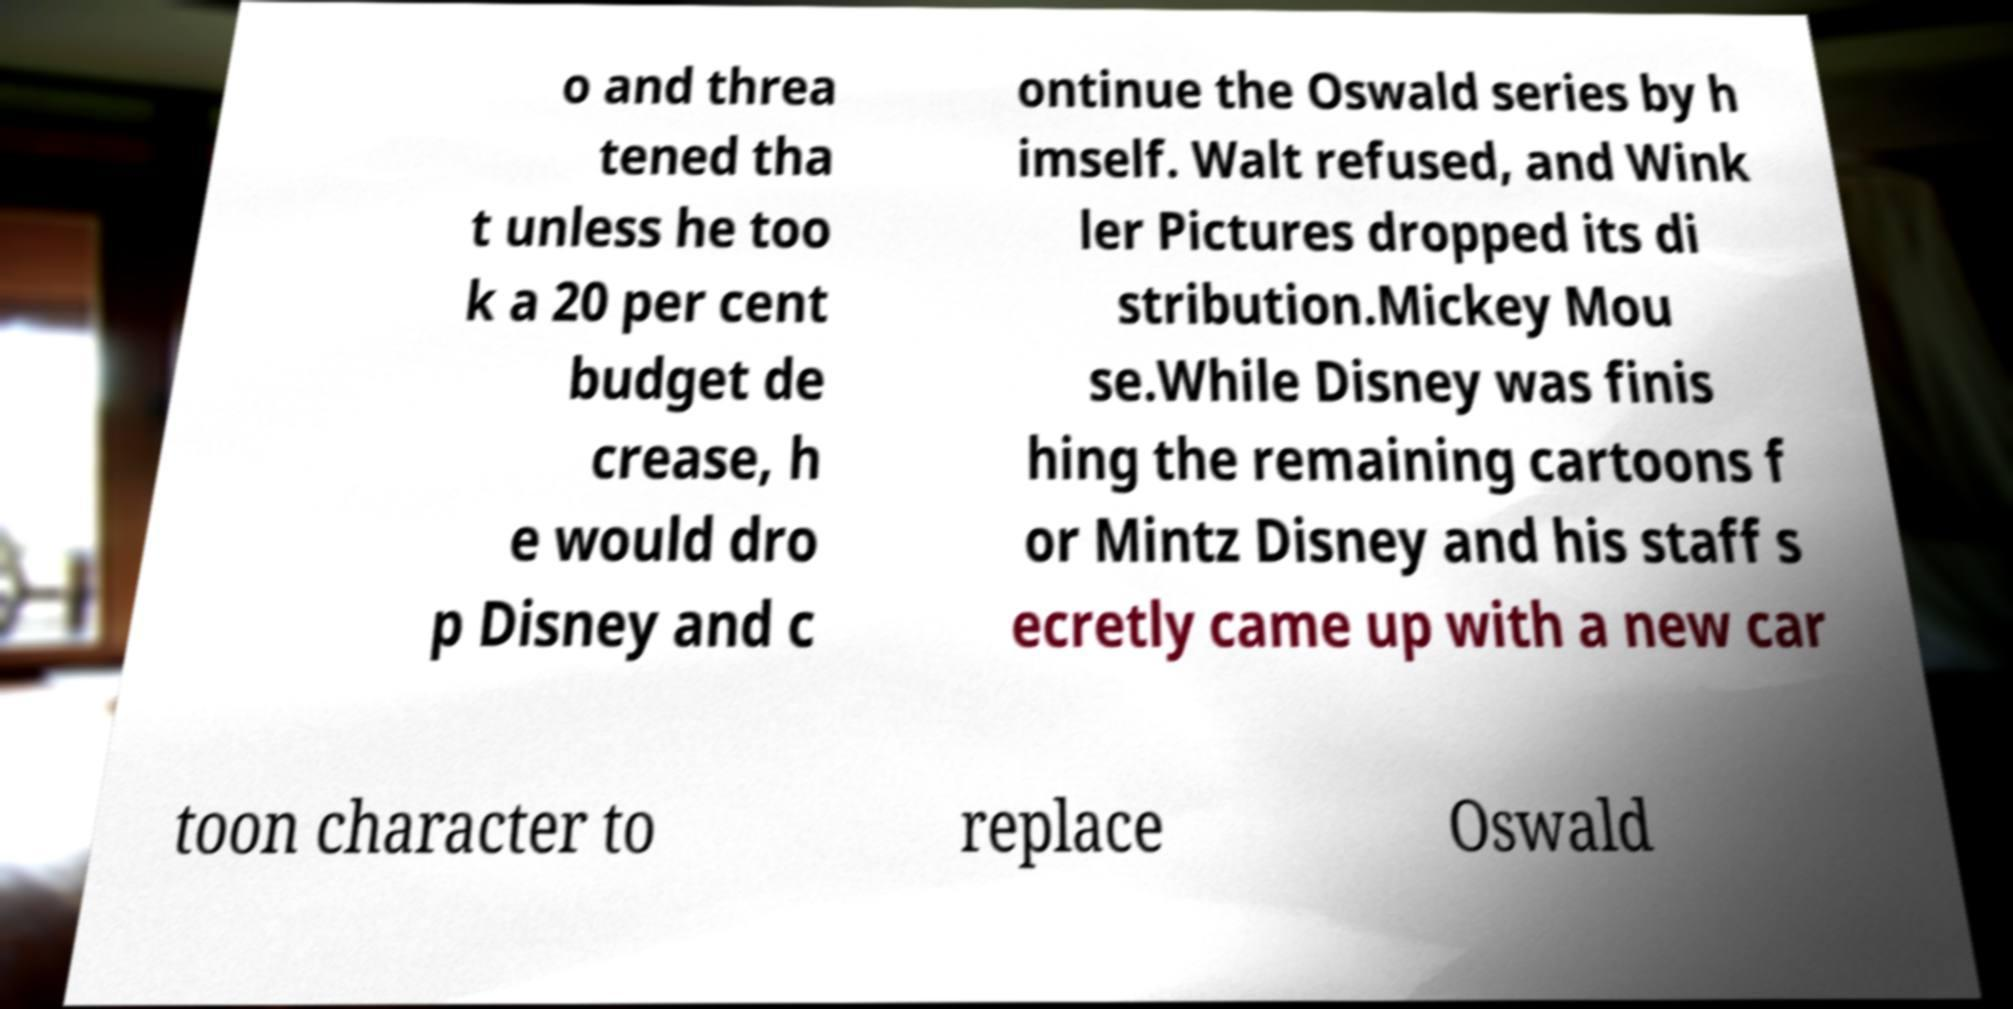For documentation purposes, I need the text within this image transcribed. Could you provide that? o and threa tened tha t unless he too k a 20 per cent budget de crease, h e would dro p Disney and c ontinue the Oswald series by h imself. Walt refused, and Wink ler Pictures dropped its di stribution.Mickey Mou se.While Disney was finis hing the remaining cartoons f or Mintz Disney and his staff s ecretly came up with a new car toon character to replace Oswald 